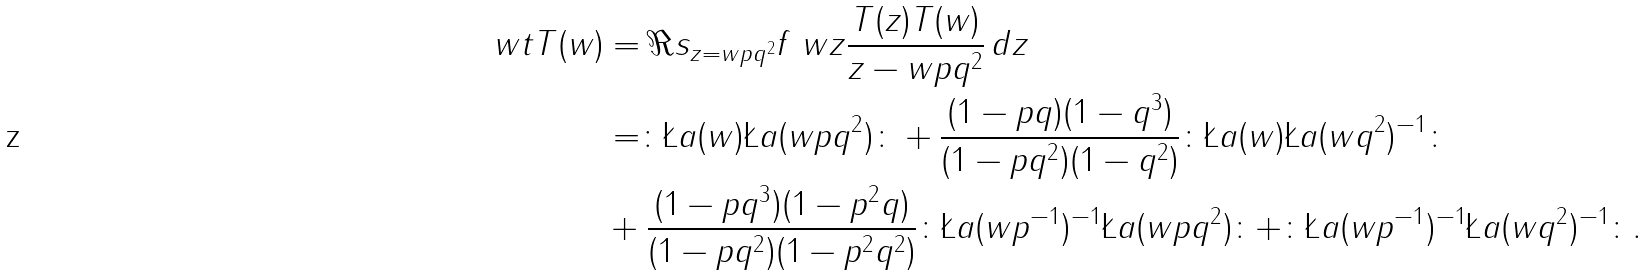Convert formula to latex. <formula><loc_0><loc_0><loc_500><loc_500>\ w t { T } ( w ) & = \Re s _ { z = w p q ^ { 2 } } f \ w z \frac { T ( z ) T ( w ) } { z - w p q ^ { 2 } } \, d z \\ & = \colon \L a ( w ) \L a ( w p q ^ { 2 } ) \colon + \frac { ( 1 - p q ) ( 1 - q ^ { 3 } ) } { ( 1 - p q ^ { 2 } ) ( 1 - q ^ { 2 } ) } \colon \L a ( w ) \L a ( w q ^ { 2 } ) ^ { - 1 } \colon \\ & + \frac { ( 1 - p q ^ { 3 } ) ( 1 - p ^ { 2 } q ) } { ( 1 - p q ^ { 2 } ) ( 1 - p ^ { 2 } q ^ { 2 } ) } \colon \L a ( w p ^ { - 1 } ) ^ { - 1 } \L a ( w p q ^ { 2 } ) \colon + \colon \L a ( w p ^ { - 1 } ) ^ { - 1 } \L a ( w q ^ { 2 } ) ^ { - 1 } \colon .</formula> 